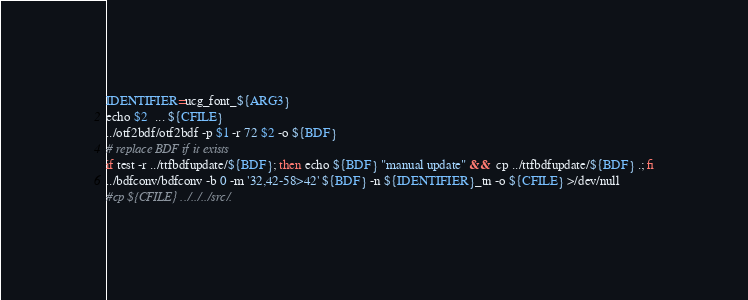Convert code to text. <code><loc_0><loc_0><loc_500><loc_500><_Bash_>IDENTIFIER=ucg_font_${ARG3}
echo $2  ... ${CFILE}
../otf2bdf/otf2bdf -p $1 -r 72 $2 -o ${BDF}
# replace BDF if it exists
if test -r ../ttfbdfupdate/${BDF}; then echo ${BDF} "manual update" &&  cp ../ttfbdfupdate/${BDF} .; fi
../bdfconv/bdfconv -b 0 -m '32,42-58>42' ${BDF} -n ${IDENTIFIER}_tn -o ${CFILE} >/dev/null
#cp ${CFILE} ../../../src/.</code> 